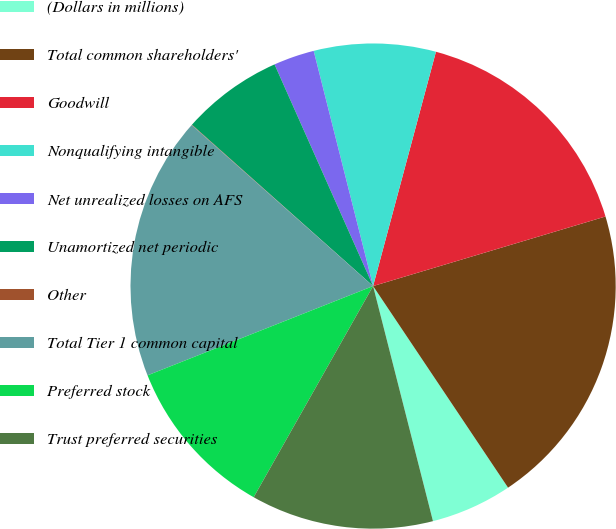<chart> <loc_0><loc_0><loc_500><loc_500><pie_chart><fcel>(Dollars in millions)<fcel>Total common shareholders'<fcel>Goodwill<fcel>Nonqualifying intangible<fcel>Net unrealized losses on AFS<fcel>Unamortized net periodic<fcel>Other<fcel>Total Tier 1 common capital<fcel>Preferred stock<fcel>Trust preferred securities<nl><fcel>5.42%<fcel>20.24%<fcel>16.2%<fcel>8.11%<fcel>2.72%<fcel>6.76%<fcel>0.03%<fcel>17.55%<fcel>10.81%<fcel>12.16%<nl></chart> 